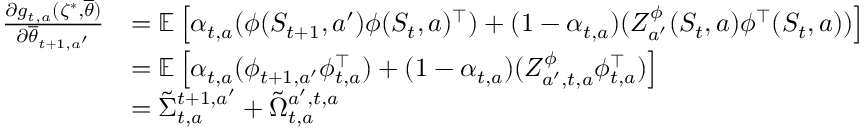Convert formula to latex. <formula><loc_0><loc_0><loc_500><loc_500>\begin{array} { r l } { \frac { \partial g _ { t , a } ( \zeta ^ { * } , \overline { \theta } ) } { \partial \overline { \theta } _ { t + 1 , a ^ { \prime } } } } & { = \mathbb { E } \left [ \alpha _ { t , a } ( \phi ( S _ { t + 1 } , a ^ { \prime } ) \phi ( S _ { t } , a ) ^ { \top } ) + ( { 1 - { \alpha } _ { t , a } } ) ( Z _ { a ^ { \prime } } ^ { \phi } ( S _ { t } , a ) \phi ^ { \top } ( S _ { t } , a ) ) \right ] } \\ & { = \mathbb { E } \left [ \alpha _ { t , a } ( \phi _ { t + 1 , a ^ { \prime } } \phi _ { t , a } ^ { \top } ) + ( { 1 - { \alpha } _ { t , a } } ) ( Z _ { a ^ { \prime } , t , a } ^ { \phi } \phi _ { t , a } ^ { \top } ) \right ] } \\ & { = \tilde { \Sigma } _ { t , a } ^ { t + 1 , a ^ { \prime } } + \tilde { \Omega } _ { t , a } ^ { { a ^ { \prime } , t , a } } } \end{array}</formula> 